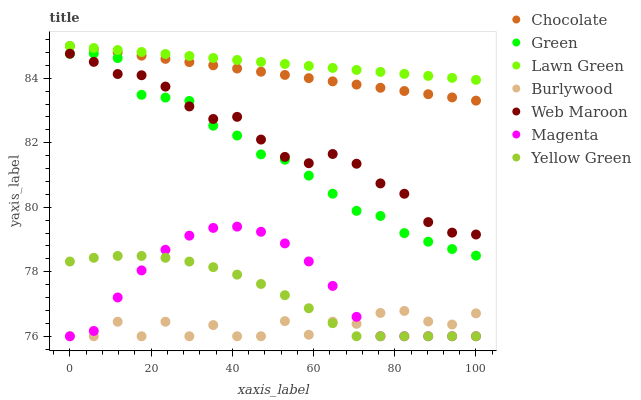Does Burlywood have the minimum area under the curve?
Answer yes or no. Yes. Does Lawn Green have the maximum area under the curve?
Answer yes or no. Yes. Does Yellow Green have the minimum area under the curve?
Answer yes or no. No. Does Yellow Green have the maximum area under the curve?
Answer yes or no. No. Is Lawn Green the smoothest?
Answer yes or no. Yes. Is Burlywood the roughest?
Answer yes or no. Yes. Is Yellow Green the smoothest?
Answer yes or no. No. Is Yellow Green the roughest?
Answer yes or no. No. Does Yellow Green have the lowest value?
Answer yes or no. Yes. Does Web Maroon have the lowest value?
Answer yes or no. No. Does Chocolate have the highest value?
Answer yes or no. Yes. Does Yellow Green have the highest value?
Answer yes or no. No. Is Green less than Chocolate?
Answer yes or no. Yes. Is Chocolate greater than Green?
Answer yes or no. Yes. Does Yellow Green intersect Magenta?
Answer yes or no. Yes. Is Yellow Green less than Magenta?
Answer yes or no. No. Is Yellow Green greater than Magenta?
Answer yes or no. No. Does Green intersect Chocolate?
Answer yes or no. No. 